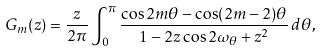<formula> <loc_0><loc_0><loc_500><loc_500>G _ { m } ( z ) = \frac { z } { 2 \pi } \int _ { 0 } ^ { \pi } \frac { \cos 2 m \theta - \cos ( 2 m - 2 ) \theta } { 1 - 2 z \cos 2 \omega _ { \theta } + z ^ { 2 } } \, d \theta ,</formula> 